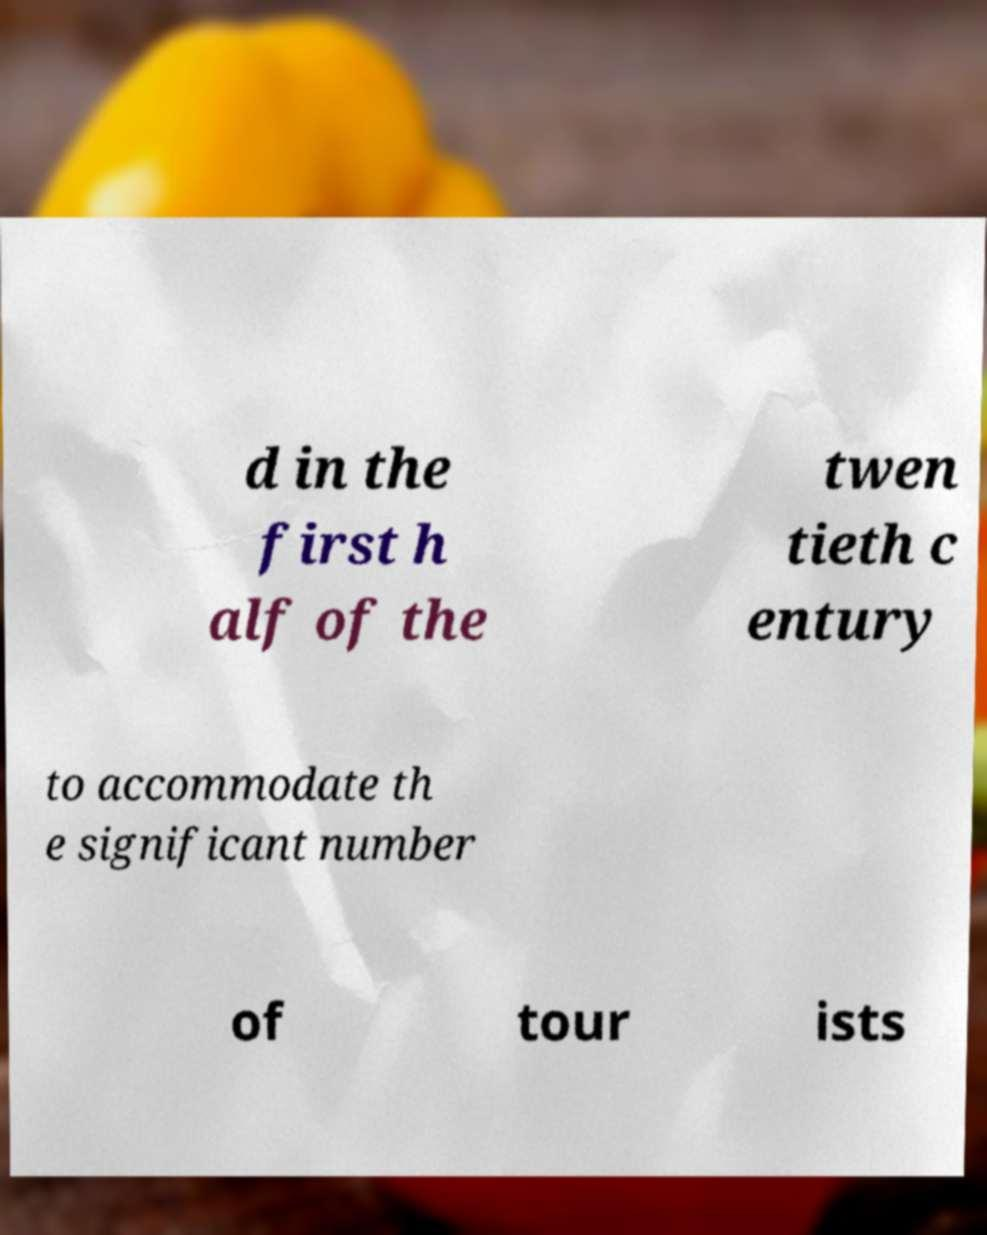Could you assist in decoding the text presented in this image and type it out clearly? d in the first h alf of the twen tieth c entury to accommodate th e significant number of tour ists 